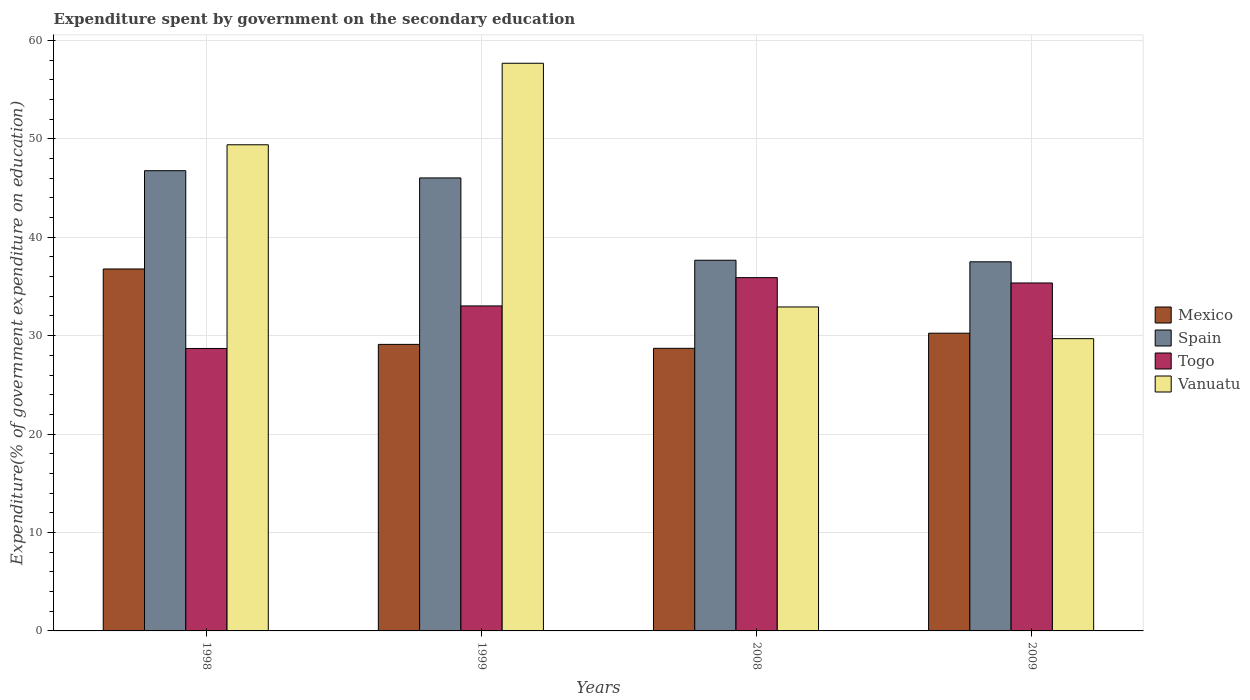How many different coloured bars are there?
Your response must be concise. 4. How many groups of bars are there?
Offer a terse response. 4. Are the number of bars per tick equal to the number of legend labels?
Your answer should be very brief. Yes. How many bars are there on the 3rd tick from the left?
Provide a succinct answer. 4. How many bars are there on the 4th tick from the right?
Your response must be concise. 4. What is the expenditure spent by government on the secondary education in Togo in 1999?
Keep it short and to the point. 33.02. Across all years, what is the maximum expenditure spent by government on the secondary education in Vanuatu?
Offer a very short reply. 57.67. Across all years, what is the minimum expenditure spent by government on the secondary education in Togo?
Provide a short and direct response. 28.7. What is the total expenditure spent by government on the secondary education in Mexico in the graph?
Provide a short and direct response. 124.84. What is the difference between the expenditure spent by government on the secondary education in Vanuatu in 1998 and that in 2008?
Keep it short and to the point. 16.48. What is the difference between the expenditure spent by government on the secondary education in Togo in 2008 and the expenditure spent by government on the secondary education in Spain in 2009?
Ensure brevity in your answer.  -1.61. What is the average expenditure spent by government on the secondary education in Spain per year?
Ensure brevity in your answer.  41.98. In the year 2008, what is the difference between the expenditure spent by government on the secondary education in Mexico and expenditure spent by government on the secondary education in Vanuatu?
Your answer should be very brief. -4.2. In how many years, is the expenditure spent by government on the secondary education in Spain greater than 16 %?
Offer a very short reply. 4. What is the ratio of the expenditure spent by government on the secondary education in Togo in 1999 to that in 2009?
Offer a very short reply. 0.93. What is the difference between the highest and the second highest expenditure spent by government on the secondary education in Mexico?
Keep it short and to the point. 6.52. What is the difference between the highest and the lowest expenditure spent by government on the secondary education in Togo?
Provide a short and direct response. 7.2. Is it the case that in every year, the sum of the expenditure spent by government on the secondary education in Mexico and expenditure spent by government on the secondary education in Vanuatu is greater than the sum of expenditure spent by government on the secondary education in Spain and expenditure spent by government on the secondary education in Togo?
Keep it short and to the point. No. What does the 4th bar from the right in 1999 represents?
Your answer should be very brief. Mexico. How many bars are there?
Ensure brevity in your answer.  16. Are all the bars in the graph horizontal?
Ensure brevity in your answer.  No. What is the difference between two consecutive major ticks on the Y-axis?
Offer a very short reply. 10. Are the values on the major ticks of Y-axis written in scientific E-notation?
Give a very brief answer. No. Does the graph contain any zero values?
Make the answer very short. No. Where does the legend appear in the graph?
Your answer should be compact. Center right. What is the title of the graph?
Your response must be concise. Expenditure spent by government on the secondary education. What is the label or title of the Y-axis?
Offer a very short reply. Expenditure(% of government expenditure on education). What is the Expenditure(% of government expenditure on education) of Mexico in 1998?
Offer a very short reply. 36.77. What is the Expenditure(% of government expenditure on education) in Spain in 1998?
Keep it short and to the point. 46.76. What is the Expenditure(% of government expenditure on education) in Togo in 1998?
Your answer should be compact. 28.7. What is the Expenditure(% of government expenditure on education) of Vanuatu in 1998?
Provide a short and direct response. 49.39. What is the Expenditure(% of government expenditure on education) in Mexico in 1999?
Provide a short and direct response. 29.11. What is the Expenditure(% of government expenditure on education) of Spain in 1999?
Ensure brevity in your answer.  46.02. What is the Expenditure(% of government expenditure on education) of Togo in 1999?
Your answer should be compact. 33.02. What is the Expenditure(% of government expenditure on education) of Vanuatu in 1999?
Offer a terse response. 57.67. What is the Expenditure(% of government expenditure on education) in Mexico in 2008?
Make the answer very short. 28.71. What is the Expenditure(% of government expenditure on education) of Spain in 2008?
Provide a succinct answer. 37.66. What is the Expenditure(% of government expenditure on education) of Togo in 2008?
Your response must be concise. 35.89. What is the Expenditure(% of government expenditure on education) in Vanuatu in 2008?
Provide a succinct answer. 32.91. What is the Expenditure(% of government expenditure on education) of Mexico in 2009?
Your answer should be very brief. 30.25. What is the Expenditure(% of government expenditure on education) in Spain in 2009?
Make the answer very short. 37.5. What is the Expenditure(% of government expenditure on education) of Togo in 2009?
Your answer should be compact. 35.35. What is the Expenditure(% of government expenditure on education) of Vanuatu in 2009?
Keep it short and to the point. 29.69. Across all years, what is the maximum Expenditure(% of government expenditure on education) of Mexico?
Ensure brevity in your answer.  36.77. Across all years, what is the maximum Expenditure(% of government expenditure on education) in Spain?
Offer a very short reply. 46.76. Across all years, what is the maximum Expenditure(% of government expenditure on education) of Togo?
Give a very brief answer. 35.89. Across all years, what is the maximum Expenditure(% of government expenditure on education) of Vanuatu?
Ensure brevity in your answer.  57.67. Across all years, what is the minimum Expenditure(% of government expenditure on education) of Mexico?
Keep it short and to the point. 28.71. Across all years, what is the minimum Expenditure(% of government expenditure on education) of Spain?
Keep it short and to the point. 37.5. Across all years, what is the minimum Expenditure(% of government expenditure on education) in Togo?
Your answer should be compact. 28.7. Across all years, what is the minimum Expenditure(% of government expenditure on education) of Vanuatu?
Provide a short and direct response. 29.69. What is the total Expenditure(% of government expenditure on education) in Mexico in the graph?
Keep it short and to the point. 124.84. What is the total Expenditure(% of government expenditure on education) in Spain in the graph?
Keep it short and to the point. 167.94. What is the total Expenditure(% of government expenditure on education) of Togo in the graph?
Provide a succinct answer. 132.96. What is the total Expenditure(% of government expenditure on education) in Vanuatu in the graph?
Keep it short and to the point. 169.67. What is the difference between the Expenditure(% of government expenditure on education) of Mexico in 1998 and that in 1999?
Your answer should be compact. 7.66. What is the difference between the Expenditure(% of government expenditure on education) of Spain in 1998 and that in 1999?
Offer a terse response. 0.73. What is the difference between the Expenditure(% of government expenditure on education) of Togo in 1998 and that in 1999?
Offer a very short reply. -4.32. What is the difference between the Expenditure(% of government expenditure on education) in Vanuatu in 1998 and that in 1999?
Your response must be concise. -8.28. What is the difference between the Expenditure(% of government expenditure on education) in Mexico in 1998 and that in 2008?
Provide a succinct answer. 8.06. What is the difference between the Expenditure(% of government expenditure on education) in Spain in 1998 and that in 2008?
Offer a terse response. 9.1. What is the difference between the Expenditure(% of government expenditure on education) in Togo in 1998 and that in 2008?
Give a very brief answer. -7.2. What is the difference between the Expenditure(% of government expenditure on education) of Vanuatu in 1998 and that in 2008?
Offer a terse response. 16.48. What is the difference between the Expenditure(% of government expenditure on education) in Mexico in 1998 and that in 2009?
Make the answer very short. 6.52. What is the difference between the Expenditure(% of government expenditure on education) in Spain in 1998 and that in 2009?
Your answer should be very brief. 9.26. What is the difference between the Expenditure(% of government expenditure on education) of Togo in 1998 and that in 2009?
Provide a succinct answer. -6.65. What is the difference between the Expenditure(% of government expenditure on education) in Vanuatu in 1998 and that in 2009?
Offer a terse response. 19.7. What is the difference between the Expenditure(% of government expenditure on education) in Mexico in 1999 and that in 2008?
Ensure brevity in your answer.  0.4. What is the difference between the Expenditure(% of government expenditure on education) in Spain in 1999 and that in 2008?
Your response must be concise. 8.36. What is the difference between the Expenditure(% of government expenditure on education) of Togo in 1999 and that in 2008?
Your answer should be very brief. -2.87. What is the difference between the Expenditure(% of government expenditure on education) in Vanuatu in 1999 and that in 2008?
Your answer should be compact. 24.76. What is the difference between the Expenditure(% of government expenditure on education) of Mexico in 1999 and that in 2009?
Your response must be concise. -1.14. What is the difference between the Expenditure(% of government expenditure on education) in Spain in 1999 and that in 2009?
Your answer should be very brief. 8.52. What is the difference between the Expenditure(% of government expenditure on education) of Togo in 1999 and that in 2009?
Your response must be concise. -2.33. What is the difference between the Expenditure(% of government expenditure on education) in Vanuatu in 1999 and that in 2009?
Offer a very short reply. 27.98. What is the difference between the Expenditure(% of government expenditure on education) of Mexico in 2008 and that in 2009?
Ensure brevity in your answer.  -1.54. What is the difference between the Expenditure(% of government expenditure on education) in Spain in 2008 and that in 2009?
Offer a very short reply. 0.16. What is the difference between the Expenditure(% of government expenditure on education) in Togo in 2008 and that in 2009?
Your answer should be very brief. 0.54. What is the difference between the Expenditure(% of government expenditure on education) in Vanuatu in 2008 and that in 2009?
Make the answer very short. 3.22. What is the difference between the Expenditure(% of government expenditure on education) of Mexico in 1998 and the Expenditure(% of government expenditure on education) of Spain in 1999?
Ensure brevity in your answer.  -9.25. What is the difference between the Expenditure(% of government expenditure on education) in Mexico in 1998 and the Expenditure(% of government expenditure on education) in Togo in 1999?
Provide a succinct answer. 3.75. What is the difference between the Expenditure(% of government expenditure on education) of Mexico in 1998 and the Expenditure(% of government expenditure on education) of Vanuatu in 1999?
Your answer should be very brief. -20.9. What is the difference between the Expenditure(% of government expenditure on education) of Spain in 1998 and the Expenditure(% of government expenditure on education) of Togo in 1999?
Your response must be concise. 13.74. What is the difference between the Expenditure(% of government expenditure on education) of Spain in 1998 and the Expenditure(% of government expenditure on education) of Vanuatu in 1999?
Give a very brief answer. -10.92. What is the difference between the Expenditure(% of government expenditure on education) of Togo in 1998 and the Expenditure(% of government expenditure on education) of Vanuatu in 1999?
Your answer should be compact. -28.98. What is the difference between the Expenditure(% of government expenditure on education) in Mexico in 1998 and the Expenditure(% of government expenditure on education) in Spain in 2008?
Your answer should be very brief. -0.89. What is the difference between the Expenditure(% of government expenditure on education) in Mexico in 1998 and the Expenditure(% of government expenditure on education) in Togo in 2008?
Offer a terse response. 0.88. What is the difference between the Expenditure(% of government expenditure on education) in Mexico in 1998 and the Expenditure(% of government expenditure on education) in Vanuatu in 2008?
Make the answer very short. 3.86. What is the difference between the Expenditure(% of government expenditure on education) in Spain in 1998 and the Expenditure(% of government expenditure on education) in Togo in 2008?
Keep it short and to the point. 10.86. What is the difference between the Expenditure(% of government expenditure on education) of Spain in 1998 and the Expenditure(% of government expenditure on education) of Vanuatu in 2008?
Your answer should be compact. 13.84. What is the difference between the Expenditure(% of government expenditure on education) in Togo in 1998 and the Expenditure(% of government expenditure on education) in Vanuatu in 2008?
Keep it short and to the point. -4.22. What is the difference between the Expenditure(% of government expenditure on education) of Mexico in 1998 and the Expenditure(% of government expenditure on education) of Spain in 2009?
Your answer should be very brief. -0.73. What is the difference between the Expenditure(% of government expenditure on education) of Mexico in 1998 and the Expenditure(% of government expenditure on education) of Togo in 2009?
Offer a very short reply. 1.42. What is the difference between the Expenditure(% of government expenditure on education) in Mexico in 1998 and the Expenditure(% of government expenditure on education) in Vanuatu in 2009?
Offer a very short reply. 7.08. What is the difference between the Expenditure(% of government expenditure on education) of Spain in 1998 and the Expenditure(% of government expenditure on education) of Togo in 2009?
Make the answer very short. 11.41. What is the difference between the Expenditure(% of government expenditure on education) of Spain in 1998 and the Expenditure(% of government expenditure on education) of Vanuatu in 2009?
Offer a very short reply. 17.06. What is the difference between the Expenditure(% of government expenditure on education) of Togo in 1998 and the Expenditure(% of government expenditure on education) of Vanuatu in 2009?
Provide a short and direct response. -1. What is the difference between the Expenditure(% of government expenditure on education) of Mexico in 1999 and the Expenditure(% of government expenditure on education) of Spain in 2008?
Provide a succinct answer. -8.55. What is the difference between the Expenditure(% of government expenditure on education) of Mexico in 1999 and the Expenditure(% of government expenditure on education) of Togo in 2008?
Keep it short and to the point. -6.78. What is the difference between the Expenditure(% of government expenditure on education) of Mexico in 1999 and the Expenditure(% of government expenditure on education) of Vanuatu in 2008?
Your response must be concise. -3.8. What is the difference between the Expenditure(% of government expenditure on education) in Spain in 1999 and the Expenditure(% of government expenditure on education) in Togo in 2008?
Offer a terse response. 10.13. What is the difference between the Expenditure(% of government expenditure on education) of Spain in 1999 and the Expenditure(% of government expenditure on education) of Vanuatu in 2008?
Provide a short and direct response. 13.11. What is the difference between the Expenditure(% of government expenditure on education) in Togo in 1999 and the Expenditure(% of government expenditure on education) in Vanuatu in 2008?
Ensure brevity in your answer.  0.1. What is the difference between the Expenditure(% of government expenditure on education) in Mexico in 1999 and the Expenditure(% of government expenditure on education) in Spain in 2009?
Provide a succinct answer. -8.39. What is the difference between the Expenditure(% of government expenditure on education) in Mexico in 1999 and the Expenditure(% of government expenditure on education) in Togo in 2009?
Ensure brevity in your answer.  -6.24. What is the difference between the Expenditure(% of government expenditure on education) in Mexico in 1999 and the Expenditure(% of government expenditure on education) in Vanuatu in 2009?
Offer a terse response. -0.58. What is the difference between the Expenditure(% of government expenditure on education) of Spain in 1999 and the Expenditure(% of government expenditure on education) of Togo in 2009?
Give a very brief answer. 10.67. What is the difference between the Expenditure(% of government expenditure on education) in Spain in 1999 and the Expenditure(% of government expenditure on education) in Vanuatu in 2009?
Your response must be concise. 16.33. What is the difference between the Expenditure(% of government expenditure on education) in Togo in 1999 and the Expenditure(% of government expenditure on education) in Vanuatu in 2009?
Offer a terse response. 3.33. What is the difference between the Expenditure(% of government expenditure on education) of Mexico in 2008 and the Expenditure(% of government expenditure on education) of Spain in 2009?
Ensure brevity in your answer.  -8.79. What is the difference between the Expenditure(% of government expenditure on education) in Mexico in 2008 and the Expenditure(% of government expenditure on education) in Togo in 2009?
Offer a terse response. -6.64. What is the difference between the Expenditure(% of government expenditure on education) in Mexico in 2008 and the Expenditure(% of government expenditure on education) in Vanuatu in 2009?
Offer a terse response. -0.98. What is the difference between the Expenditure(% of government expenditure on education) in Spain in 2008 and the Expenditure(% of government expenditure on education) in Togo in 2009?
Provide a succinct answer. 2.31. What is the difference between the Expenditure(% of government expenditure on education) of Spain in 2008 and the Expenditure(% of government expenditure on education) of Vanuatu in 2009?
Your answer should be compact. 7.97. What is the difference between the Expenditure(% of government expenditure on education) of Togo in 2008 and the Expenditure(% of government expenditure on education) of Vanuatu in 2009?
Offer a terse response. 6.2. What is the average Expenditure(% of government expenditure on education) of Mexico per year?
Make the answer very short. 31.21. What is the average Expenditure(% of government expenditure on education) of Spain per year?
Provide a short and direct response. 41.98. What is the average Expenditure(% of government expenditure on education) of Togo per year?
Ensure brevity in your answer.  33.24. What is the average Expenditure(% of government expenditure on education) of Vanuatu per year?
Keep it short and to the point. 42.42. In the year 1998, what is the difference between the Expenditure(% of government expenditure on education) of Mexico and Expenditure(% of government expenditure on education) of Spain?
Your answer should be very brief. -9.98. In the year 1998, what is the difference between the Expenditure(% of government expenditure on education) of Mexico and Expenditure(% of government expenditure on education) of Togo?
Provide a succinct answer. 8.08. In the year 1998, what is the difference between the Expenditure(% of government expenditure on education) of Mexico and Expenditure(% of government expenditure on education) of Vanuatu?
Provide a short and direct response. -12.62. In the year 1998, what is the difference between the Expenditure(% of government expenditure on education) in Spain and Expenditure(% of government expenditure on education) in Togo?
Offer a terse response. 18.06. In the year 1998, what is the difference between the Expenditure(% of government expenditure on education) of Spain and Expenditure(% of government expenditure on education) of Vanuatu?
Provide a succinct answer. -2.63. In the year 1998, what is the difference between the Expenditure(% of government expenditure on education) in Togo and Expenditure(% of government expenditure on education) in Vanuatu?
Make the answer very short. -20.69. In the year 1999, what is the difference between the Expenditure(% of government expenditure on education) in Mexico and Expenditure(% of government expenditure on education) in Spain?
Give a very brief answer. -16.91. In the year 1999, what is the difference between the Expenditure(% of government expenditure on education) of Mexico and Expenditure(% of government expenditure on education) of Togo?
Ensure brevity in your answer.  -3.91. In the year 1999, what is the difference between the Expenditure(% of government expenditure on education) in Mexico and Expenditure(% of government expenditure on education) in Vanuatu?
Your answer should be compact. -28.56. In the year 1999, what is the difference between the Expenditure(% of government expenditure on education) in Spain and Expenditure(% of government expenditure on education) in Togo?
Your answer should be compact. 13. In the year 1999, what is the difference between the Expenditure(% of government expenditure on education) in Spain and Expenditure(% of government expenditure on education) in Vanuatu?
Provide a succinct answer. -11.65. In the year 1999, what is the difference between the Expenditure(% of government expenditure on education) of Togo and Expenditure(% of government expenditure on education) of Vanuatu?
Offer a terse response. -24.65. In the year 2008, what is the difference between the Expenditure(% of government expenditure on education) of Mexico and Expenditure(% of government expenditure on education) of Spain?
Your answer should be compact. -8.95. In the year 2008, what is the difference between the Expenditure(% of government expenditure on education) of Mexico and Expenditure(% of government expenditure on education) of Togo?
Your answer should be compact. -7.18. In the year 2008, what is the difference between the Expenditure(% of government expenditure on education) of Mexico and Expenditure(% of government expenditure on education) of Vanuatu?
Keep it short and to the point. -4.2. In the year 2008, what is the difference between the Expenditure(% of government expenditure on education) in Spain and Expenditure(% of government expenditure on education) in Togo?
Offer a terse response. 1.77. In the year 2008, what is the difference between the Expenditure(% of government expenditure on education) of Spain and Expenditure(% of government expenditure on education) of Vanuatu?
Provide a succinct answer. 4.75. In the year 2008, what is the difference between the Expenditure(% of government expenditure on education) of Togo and Expenditure(% of government expenditure on education) of Vanuatu?
Your response must be concise. 2.98. In the year 2009, what is the difference between the Expenditure(% of government expenditure on education) in Mexico and Expenditure(% of government expenditure on education) in Spain?
Keep it short and to the point. -7.25. In the year 2009, what is the difference between the Expenditure(% of government expenditure on education) of Mexico and Expenditure(% of government expenditure on education) of Togo?
Provide a short and direct response. -5.1. In the year 2009, what is the difference between the Expenditure(% of government expenditure on education) of Mexico and Expenditure(% of government expenditure on education) of Vanuatu?
Your answer should be compact. 0.56. In the year 2009, what is the difference between the Expenditure(% of government expenditure on education) of Spain and Expenditure(% of government expenditure on education) of Togo?
Your response must be concise. 2.15. In the year 2009, what is the difference between the Expenditure(% of government expenditure on education) of Spain and Expenditure(% of government expenditure on education) of Vanuatu?
Offer a very short reply. 7.81. In the year 2009, what is the difference between the Expenditure(% of government expenditure on education) of Togo and Expenditure(% of government expenditure on education) of Vanuatu?
Keep it short and to the point. 5.66. What is the ratio of the Expenditure(% of government expenditure on education) in Mexico in 1998 to that in 1999?
Ensure brevity in your answer.  1.26. What is the ratio of the Expenditure(% of government expenditure on education) in Spain in 1998 to that in 1999?
Provide a short and direct response. 1.02. What is the ratio of the Expenditure(% of government expenditure on education) of Togo in 1998 to that in 1999?
Offer a terse response. 0.87. What is the ratio of the Expenditure(% of government expenditure on education) in Vanuatu in 1998 to that in 1999?
Make the answer very short. 0.86. What is the ratio of the Expenditure(% of government expenditure on education) of Mexico in 1998 to that in 2008?
Your answer should be very brief. 1.28. What is the ratio of the Expenditure(% of government expenditure on education) of Spain in 1998 to that in 2008?
Your answer should be compact. 1.24. What is the ratio of the Expenditure(% of government expenditure on education) in Togo in 1998 to that in 2008?
Give a very brief answer. 0.8. What is the ratio of the Expenditure(% of government expenditure on education) of Vanuatu in 1998 to that in 2008?
Offer a terse response. 1.5. What is the ratio of the Expenditure(% of government expenditure on education) of Mexico in 1998 to that in 2009?
Ensure brevity in your answer.  1.22. What is the ratio of the Expenditure(% of government expenditure on education) in Spain in 1998 to that in 2009?
Keep it short and to the point. 1.25. What is the ratio of the Expenditure(% of government expenditure on education) in Togo in 1998 to that in 2009?
Offer a terse response. 0.81. What is the ratio of the Expenditure(% of government expenditure on education) of Vanuatu in 1998 to that in 2009?
Offer a very short reply. 1.66. What is the ratio of the Expenditure(% of government expenditure on education) in Mexico in 1999 to that in 2008?
Offer a very short reply. 1.01. What is the ratio of the Expenditure(% of government expenditure on education) of Spain in 1999 to that in 2008?
Give a very brief answer. 1.22. What is the ratio of the Expenditure(% of government expenditure on education) of Togo in 1999 to that in 2008?
Make the answer very short. 0.92. What is the ratio of the Expenditure(% of government expenditure on education) of Vanuatu in 1999 to that in 2008?
Ensure brevity in your answer.  1.75. What is the ratio of the Expenditure(% of government expenditure on education) of Mexico in 1999 to that in 2009?
Offer a very short reply. 0.96. What is the ratio of the Expenditure(% of government expenditure on education) in Spain in 1999 to that in 2009?
Ensure brevity in your answer.  1.23. What is the ratio of the Expenditure(% of government expenditure on education) in Togo in 1999 to that in 2009?
Provide a succinct answer. 0.93. What is the ratio of the Expenditure(% of government expenditure on education) of Vanuatu in 1999 to that in 2009?
Your answer should be very brief. 1.94. What is the ratio of the Expenditure(% of government expenditure on education) in Mexico in 2008 to that in 2009?
Your answer should be compact. 0.95. What is the ratio of the Expenditure(% of government expenditure on education) in Spain in 2008 to that in 2009?
Your answer should be very brief. 1. What is the ratio of the Expenditure(% of government expenditure on education) of Togo in 2008 to that in 2009?
Ensure brevity in your answer.  1.02. What is the ratio of the Expenditure(% of government expenditure on education) of Vanuatu in 2008 to that in 2009?
Give a very brief answer. 1.11. What is the difference between the highest and the second highest Expenditure(% of government expenditure on education) in Mexico?
Make the answer very short. 6.52. What is the difference between the highest and the second highest Expenditure(% of government expenditure on education) in Spain?
Offer a very short reply. 0.73. What is the difference between the highest and the second highest Expenditure(% of government expenditure on education) of Togo?
Provide a short and direct response. 0.54. What is the difference between the highest and the second highest Expenditure(% of government expenditure on education) of Vanuatu?
Provide a short and direct response. 8.28. What is the difference between the highest and the lowest Expenditure(% of government expenditure on education) in Mexico?
Give a very brief answer. 8.06. What is the difference between the highest and the lowest Expenditure(% of government expenditure on education) in Spain?
Provide a short and direct response. 9.26. What is the difference between the highest and the lowest Expenditure(% of government expenditure on education) of Togo?
Provide a succinct answer. 7.2. What is the difference between the highest and the lowest Expenditure(% of government expenditure on education) of Vanuatu?
Provide a succinct answer. 27.98. 